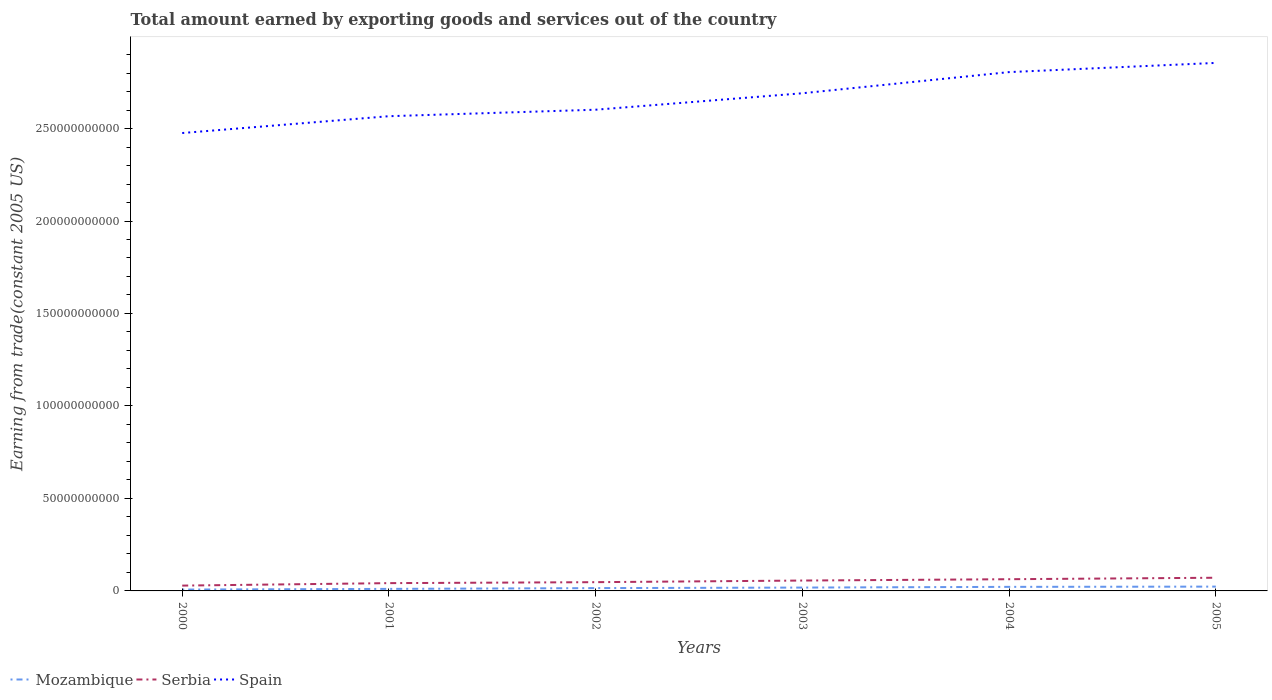How many different coloured lines are there?
Your answer should be very brief. 3. Does the line corresponding to Serbia intersect with the line corresponding to Spain?
Offer a terse response. No. Is the number of lines equal to the number of legend labels?
Provide a short and direct response. Yes. Across all years, what is the maximum total amount earned by exporting goods and services in Spain?
Offer a very short reply. 2.48e+11. In which year was the total amount earned by exporting goods and services in Mozambique maximum?
Your answer should be very brief. 2000. What is the total total amount earned by exporting goods and services in Spain in the graph?
Provide a succinct answer. -2.15e+1. What is the difference between the highest and the second highest total amount earned by exporting goods and services in Mozambique?
Offer a terse response. 1.60e+09. Is the total amount earned by exporting goods and services in Serbia strictly greater than the total amount earned by exporting goods and services in Spain over the years?
Provide a short and direct response. Yes. Does the graph contain any zero values?
Your answer should be compact. No. Does the graph contain grids?
Your answer should be compact. No. Where does the legend appear in the graph?
Your answer should be compact. Bottom left. How many legend labels are there?
Provide a short and direct response. 3. What is the title of the graph?
Offer a terse response. Total amount earned by exporting goods and services out of the country. Does "Dominica" appear as one of the legend labels in the graph?
Ensure brevity in your answer.  No. What is the label or title of the Y-axis?
Offer a very short reply. Earning from trade(constant 2005 US). What is the Earning from trade(constant 2005 US) in Mozambique in 2000?
Your answer should be compact. 7.31e+08. What is the Earning from trade(constant 2005 US) in Serbia in 2000?
Offer a very short reply. 2.88e+09. What is the Earning from trade(constant 2005 US) of Spain in 2000?
Provide a succinct answer. 2.48e+11. What is the Earning from trade(constant 2005 US) in Mozambique in 2001?
Make the answer very short. 1.10e+09. What is the Earning from trade(constant 2005 US) in Serbia in 2001?
Keep it short and to the point. 4.21e+09. What is the Earning from trade(constant 2005 US) in Spain in 2001?
Ensure brevity in your answer.  2.57e+11. What is the Earning from trade(constant 2005 US) of Mozambique in 2002?
Offer a terse response. 1.52e+09. What is the Earning from trade(constant 2005 US) in Serbia in 2002?
Your answer should be compact. 4.73e+09. What is the Earning from trade(constant 2005 US) of Spain in 2002?
Give a very brief answer. 2.60e+11. What is the Earning from trade(constant 2005 US) of Mozambique in 2003?
Offer a terse response. 1.81e+09. What is the Earning from trade(constant 2005 US) in Serbia in 2003?
Keep it short and to the point. 5.61e+09. What is the Earning from trade(constant 2005 US) of Spain in 2003?
Your answer should be very brief. 2.69e+11. What is the Earning from trade(constant 2005 US) of Mozambique in 2004?
Offer a terse response. 2.19e+09. What is the Earning from trade(constant 2005 US) of Serbia in 2004?
Your response must be concise. 6.33e+09. What is the Earning from trade(constant 2005 US) of Spain in 2004?
Provide a short and direct response. 2.81e+11. What is the Earning from trade(constant 2005 US) in Mozambique in 2005?
Keep it short and to the point. 2.33e+09. What is the Earning from trade(constant 2005 US) in Serbia in 2005?
Make the answer very short. 7.13e+09. What is the Earning from trade(constant 2005 US) of Spain in 2005?
Keep it short and to the point. 2.85e+11. Across all years, what is the maximum Earning from trade(constant 2005 US) of Mozambique?
Give a very brief answer. 2.33e+09. Across all years, what is the maximum Earning from trade(constant 2005 US) of Serbia?
Ensure brevity in your answer.  7.13e+09. Across all years, what is the maximum Earning from trade(constant 2005 US) of Spain?
Provide a short and direct response. 2.85e+11. Across all years, what is the minimum Earning from trade(constant 2005 US) of Mozambique?
Provide a short and direct response. 7.31e+08. Across all years, what is the minimum Earning from trade(constant 2005 US) of Serbia?
Ensure brevity in your answer.  2.88e+09. Across all years, what is the minimum Earning from trade(constant 2005 US) of Spain?
Ensure brevity in your answer.  2.48e+11. What is the total Earning from trade(constant 2005 US) of Mozambique in the graph?
Give a very brief answer. 9.69e+09. What is the total Earning from trade(constant 2005 US) of Serbia in the graph?
Provide a succinct answer. 3.09e+1. What is the total Earning from trade(constant 2005 US) of Spain in the graph?
Your answer should be compact. 1.60e+12. What is the difference between the Earning from trade(constant 2005 US) of Mozambique in 2000 and that in 2001?
Provide a succinct answer. -3.69e+08. What is the difference between the Earning from trade(constant 2005 US) of Serbia in 2000 and that in 2001?
Your answer should be very brief. -1.33e+09. What is the difference between the Earning from trade(constant 2005 US) of Spain in 2000 and that in 2001?
Your answer should be very brief. -9.10e+09. What is the difference between the Earning from trade(constant 2005 US) in Mozambique in 2000 and that in 2002?
Provide a short and direct response. -7.90e+08. What is the difference between the Earning from trade(constant 2005 US) of Serbia in 2000 and that in 2002?
Keep it short and to the point. -1.86e+09. What is the difference between the Earning from trade(constant 2005 US) in Spain in 2000 and that in 2002?
Offer a terse response. -1.26e+1. What is the difference between the Earning from trade(constant 2005 US) in Mozambique in 2000 and that in 2003?
Make the answer very short. -1.08e+09. What is the difference between the Earning from trade(constant 2005 US) in Serbia in 2000 and that in 2003?
Give a very brief answer. -2.73e+09. What is the difference between the Earning from trade(constant 2005 US) in Spain in 2000 and that in 2003?
Provide a short and direct response. -2.15e+1. What is the difference between the Earning from trade(constant 2005 US) of Mozambique in 2000 and that in 2004?
Give a very brief answer. -1.46e+09. What is the difference between the Earning from trade(constant 2005 US) of Serbia in 2000 and that in 2004?
Make the answer very short. -3.46e+09. What is the difference between the Earning from trade(constant 2005 US) of Spain in 2000 and that in 2004?
Ensure brevity in your answer.  -3.29e+1. What is the difference between the Earning from trade(constant 2005 US) of Mozambique in 2000 and that in 2005?
Offer a terse response. -1.60e+09. What is the difference between the Earning from trade(constant 2005 US) in Serbia in 2000 and that in 2005?
Your answer should be very brief. -4.25e+09. What is the difference between the Earning from trade(constant 2005 US) of Spain in 2000 and that in 2005?
Your response must be concise. -3.79e+1. What is the difference between the Earning from trade(constant 2005 US) of Mozambique in 2001 and that in 2002?
Keep it short and to the point. -4.21e+08. What is the difference between the Earning from trade(constant 2005 US) of Serbia in 2001 and that in 2002?
Ensure brevity in your answer.  -5.24e+08. What is the difference between the Earning from trade(constant 2005 US) in Spain in 2001 and that in 2002?
Provide a short and direct response. -3.51e+09. What is the difference between the Earning from trade(constant 2005 US) in Mozambique in 2001 and that in 2003?
Offer a very short reply. -7.10e+08. What is the difference between the Earning from trade(constant 2005 US) in Serbia in 2001 and that in 2003?
Give a very brief answer. -1.40e+09. What is the difference between the Earning from trade(constant 2005 US) of Spain in 2001 and that in 2003?
Provide a short and direct response. -1.24e+1. What is the difference between the Earning from trade(constant 2005 US) in Mozambique in 2001 and that in 2004?
Make the answer very short. -1.09e+09. What is the difference between the Earning from trade(constant 2005 US) in Serbia in 2001 and that in 2004?
Provide a short and direct response. -2.12e+09. What is the difference between the Earning from trade(constant 2005 US) of Spain in 2001 and that in 2004?
Give a very brief answer. -2.38e+1. What is the difference between the Earning from trade(constant 2005 US) in Mozambique in 2001 and that in 2005?
Your answer should be compact. -1.23e+09. What is the difference between the Earning from trade(constant 2005 US) of Serbia in 2001 and that in 2005?
Provide a short and direct response. -2.92e+09. What is the difference between the Earning from trade(constant 2005 US) in Spain in 2001 and that in 2005?
Make the answer very short. -2.88e+1. What is the difference between the Earning from trade(constant 2005 US) in Mozambique in 2002 and that in 2003?
Your answer should be very brief. -2.88e+08. What is the difference between the Earning from trade(constant 2005 US) in Serbia in 2002 and that in 2003?
Your answer should be very brief. -8.75e+08. What is the difference between the Earning from trade(constant 2005 US) of Spain in 2002 and that in 2003?
Give a very brief answer. -8.90e+09. What is the difference between the Earning from trade(constant 2005 US) in Mozambique in 2002 and that in 2004?
Provide a succinct answer. -6.73e+08. What is the difference between the Earning from trade(constant 2005 US) of Serbia in 2002 and that in 2004?
Ensure brevity in your answer.  -1.60e+09. What is the difference between the Earning from trade(constant 2005 US) in Spain in 2002 and that in 2004?
Ensure brevity in your answer.  -2.03e+1. What is the difference between the Earning from trade(constant 2005 US) of Mozambique in 2002 and that in 2005?
Offer a very short reply. -8.11e+08. What is the difference between the Earning from trade(constant 2005 US) in Serbia in 2002 and that in 2005?
Ensure brevity in your answer.  -2.39e+09. What is the difference between the Earning from trade(constant 2005 US) of Spain in 2002 and that in 2005?
Keep it short and to the point. -2.53e+1. What is the difference between the Earning from trade(constant 2005 US) of Mozambique in 2003 and that in 2004?
Offer a very short reply. -3.85e+08. What is the difference between the Earning from trade(constant 2005 US) of Serbia in 2003 and that in 2004?
Your answer should be compact. -7.25e+08. What is the difference between the Earning from trade(constant 2005 US) in Spain in 2003 and that in 2004?
Offer a terse response. -1.14e+1. What is the difference between the Earning from trade(constant 2005 US) of Mozambique in 2003 and that in 2005?
Ensure brevity in your answer.  -5.22e+08. What is the difference between the Earning from trade(constant 2005 US) of Serbia in 2003 and that in 2005?
Your response must be concise. -1.52e+09. What is the difference between the Earning from trade(constant 2005 US) in Spain in 2003 and that in 2005?
Keep it short and to the point. -1.64e+1. What is the difference between the Earning from trade(constant 2005 US) of Mozambique in 2004 and that in 2005?
Your answer should be compact. -1.38e+08. What is the difference between the Earning from trade(constant 2005 US) in Serbia in 2004 and that in 2005?
Your answer should be compact. -7.92e+08. What is the difference between the Earning from trade(constant 2005 US) in Spain in 2004 and that in 2005?
Your answer should be very brief. -4.97e+09. What is the difference between the Earning from trade(constant 2005 US) in Mozambique in 2000 and the Earning from trade(constant 2005 US) in Serbia in 2001?
Ensure brevity in your answer.  -3.48e+09. What is the difference between the Earning from trade(constant 2005 US) of Mozambique in 2000 and the Earning from trade(constant 2005 US) of Spain in 2001?
Provide a short and direct response. -2.56e+11. What is the difference between the Earning from trade(constant 2005 US) of Serbia in 2000 and the Earning from trade(constant 2005 US) of Spain in 2001?
Provide a succinct answer. -2.54e+11. What is the difference between the Earning from trade(constant 2005 US) of Mozambique in 2000 and the Earning from trade(constant 2005 US) of Serbia in 2002?
Ensure brevity in your answer.  -4.00e+09. What is the difference between the Earning from trade(constant 2005 US) of Mozambique in 2000 and the Earning from trade(constant 2005 US) of Spain in 2002?
Provide a short and direct response. -2.59e+11. What is the difference between the Earning from trade(constant 2005 US) of Serbia in 2000 and the Earning from trade(constant 2005 US) of Spain in 2002?
Ensure brevity in your answer.  -2.57e+11. What is the difference between the Earning from trade(constant 2005 US) in Mozambique in 2000 and the Earning from trade(constant 2005 US) in Serbia in 2003?
Provide a short and direct response. -4.88e+09. What is the difference between the Earning from trade(constant 2005 US) of Mozambique in 2000 and the Earning from trade(constant 2005 US) of Spain in 2003?
Make the answer very short. -2.68e+11. What is the difference between the Earning from trade(constant 2005 US) of Serbia in 2000 and the Earning from trade(constant 2005 US) of Spain in 2003?
Keep it short and to the point. -2.66e+11. What is the difference between the Earning from trade(constant 2005 US) in Mozambique in 2000 and the Earning from trade(constant 2005 US) in Serbia in 2004?
Your answer should be compact. -5.60e+09. What is the difference between the Earning from trade(constant 2005 US) of Mozambique in 2000 and the Earning from trade(constant 2005 US) of Spain in 2004?
Ensure brevity in your answer.  -2.80e+11. What is the difference between the Earning from trade(constant 2005 US) in Serbia in 2000 and the Earning from trade(constant 2005 US) in Spain in 2004?
Keep it short and to the point. -2.78e+11. What is the difference between the Earning from trade(constant 2005 US) of Mozambique in 2000 and the Earning from trade(constant 2005 US) of Serbia in 2005?
Make the answer very short. -6.39e+09. What is the difference between the Earning from trade(constant 2005 US) of Mozambique in 2000 and the Earning from trade(constant 2005 US) of Spain in 2005?
Offer a very short reply. -2.85e+11. What is the difference between the Earning from trade(constant 2005 US) in Serbia in 2000 and the Earning from trade(constant 2005 US) in Spain in 2005?
Give a very brief answer. -2.83e+11. What is the difference between the Earning from trade(constant 2005 US) of Mozambique in 2001 and the Earning from trade(constant 2005 US) of Serbia in 2002?
Your answer should be very brief. -3.63e+09. What is the difference between the Earning from trade(constant 2005 US) in Mozambique in 2001 and the Earning from trade(constant 2005 US) in Spain in 2002?
Ensure brevity in your answer.  -2.59e+11. What is the difference between the Earning from trade(constant 2005 US) of Serbia in 2001 and the Earning from trade(constant 2005 US) of Spain in 2002?
Make the answer very short. -2.56e+11. What is the difference between the Earning from trade(constant 2005 US) of Mozambique in 2001 and the Earning from trade(constant 2005 US) of Serbia in 2003?
Give a very brief answer. -4.51e+09. What is the difference between the Earning from trade(constant 2005 US) of Mozambique in 2001 and the Earning from trade(constant 2005 US) of Spain in 2003?
Offer a very short reply. -2.68e+11. What is the difference between the Earning from trade(constant 2005 US) of Serbia in 2001 and the Earning from trade(constant 2005 US) of Spain in 2003?
Offer a very short reply. -2.65e+11. What is the difference between the Earning from trade(constant 2005 US) in Mozambique in 2001 and the Earning from trade(constant 2005 US) in Serbia in 2004?
Offer a very short reply. -5.23e+09. What is the difference between the Earning from trade(constant 2005 US) of Mozambique in 2001 and the Earning from trade(constant 2005 US) of Spain in 2004?
Make the answer very short. -2.79e+11. What is the difference between the Earning from trade(constant 2005 US) in Serbia in 2001 and the Earning from trade(constant 2005 US) in Spain in 2004?
Keep it short and to the point. -2.76e+11. What is the difference between the Earning from trade(constant 2005 US) of Mozambique in 2001 and the Earning from trade(constant 2005 US) of Serbia in 2005?
Provide a succinct answer. -6.03e+09. What is the difference between the Earning from trade(constant 2005 US) in Mozambique in 2001 and the Earning from trade(constant 2005 US) in Spain in 2005?
Your response must be concise. -2.84e+11. What is the difference between the Earning from trade(constant 2005 US) of Serbia in 2001 and the Earning from trade(constant 2005 US) of Spain in 2005?
Offer a terse response. -2.81e+11. What is the difference between the Earning from trade(constant 2005 US) in Mozambique in 2002 and the Earning from trade(constant 2005 US) in Serbia in 2003?
Provide a short and direct response. -4.09e+09. What is the difference between the Earning from trade(constant 2005 US) of Mozambique in 2002 and the Earning from trade(constant 2005 US) of Spain in 2003?
Offer a very short reply. -2.68e+11. What is the difference between the Earning from trade(constant 2005 US) in Serbia in 2002 and the Earning from trade(constant 2005 US) in Spain in 2003?
Your answer should be compact. -2.64e+11. What is the difference between the Earning from trade(constant 2005 US) in Mozambique in 2002 and the Earning from trade(constant 2005 US) in Serbia in 2004?
Provide a short and direct response. -4.81e+09. What is the difference between the Earning from trade(constant 2005 US) of Mozambique in 2002 and the Earning from trade(constant 2005 US) of Spain in 2004?
Ensure brevity in your answer.  -2.79e+11. What is the difference between the Earning from trade(constant 2005 US) of Serbia in 2002 and the Earning from trade(constant 2005 US) of Spain in 2004?
Make the answer very short. -2.76e+11. What is the difference between the Earning from trade(constant 2005 US) in Mozambique in 2002 and the Earning from trade(constant 2005 US) in Serbia in 2005?
Ensure brevity in your answer.  -5.60e+09. What is the difference between the Earning from trade(constant 2005 US) of Mozambique in 2002 and the Earning from trade(constant 2005 US) of Spain in 2005?
Your answer should be compact. -2.84e+11. What is the difference between the Earning from trade(constant 2005 US) in Serbia in 2002 and the Earning from trade(constant 2005 US) in Spain in 2005?
Give a very brief answer. -2.81e+11. What is the difference between the Earning from trade(constant 2005 US) in Mozambique in 2003 and the Earning from trade(constant 2005 US) in Serbia in 2004?
Give a very brief answer. -4.52e+09. What is the difference between the Earning from trade(constant 2005 US) in Mozambique in 2003 and the Earning from trade(constant 2005 US) in Spain in 2004?
Ensure brevity in your answer.  -2.79e+11. What is the difference between the Earning from trade(constant 2005 US) in Serbia in 2003 and the Earning from trade(constant 2005 US) in Spain in 2004?
Offer a terse response. -2.75e+11. What is the difference between the Earning from trade(constant 2005 US) of Mozambique in 2003 and the Earning from trade(constant 2005 US) of Serbia in 2005?
Make the answer very short. -5.32e+09. What is the difference between the Earning from trade(constant 2005 US) of Mozambique in 2003 and the Earning from trade(constant 2005 US) of Spain in 2005?
Make the answer very short. -2.84e+11. What is the difference between the Earning from trade(constant 2005 US) of Serbia in 2003 and the Earning from trade(constant 2005 US) of Spain in 2005?
Your answer should be compact. -2.80e+11. What is the difference between the Earning from trade(constant 2005 US) in Mozambique in 2004 and the Earning from trade(constant 2005 US) in Serbia in 2005?
Your answer should be very brief. -4.93e+09. What is the difference between the Earning from trade(constant 2005 US) in Mozambique in 2004 and the Earning from trade(constant 2005 US) in Spain in 2005?
Keep it short and to the point. -2.83e+11. What is the difference between the Earning from trade(constant 2005 US) in Serbia in 2004 and the Earning from trade(constant 2005 US) in Spain in 2005?
Your response must be concise. -2.79e+11. What is the average Earning from trade(constant 2005 US) in Mozambique per year?
Your answer should be compact. 1.61e+09. What is the average Earning from trade(constant 2005 US) in Serbia per year?
Your answer should be compact. 5.15e+09. What is the average Earning from trade(constant 2005 US) of Spain per year?
Your answer should be very brief. 2.67e+11. In the year 2000, what is the difference between the Earning from trade(constant 2005 US) in Mozambique and Earning from trade(constant 2005 US) in Serbia?
Offer a very short reply. -2.14e+09. In the year 2000, what is the difference between the Earning from trade(constant 2005 US) in Mozambique and Earning from trade(constant 2005 US) in Spain?
Ensure brevity in your answer.  -2.47e+11. In the year 2000, what is the difference between the Earning from trade(constant 2005 US) of Serbia and Earning from trade(constant 2005 US) of Spain?
Your answer should be very brief. -2.45e+11. In the year 2001, what is the difference between the Earning from trade(constant 2005 US) of Mozambique and Earning from trade(constant 2005 US) of Serbia?
Your answer should be compact. -3.11e+09. In the year 2001, what is the difference between the Earning from trade(constant 2005 US) in Mozambique and Earning from trade(constant 2005 US) in Spain?
Offer a very short reply. -2.56e+11. In the year 2001, what is the difference between the Earning from trade(constant 2005 US) in Serbia and Earning from trade(constant 2005 US) in Spain?
Provide a short and direct response. -2.52e+11. In the year 2002, what is the difference between the Earning from trade(constant 2005 US) of Mozambique and Earning from trade(constant 2005 US) of Serbia?
Your response must be concise. -3.21e+09. In the year 2002, what is the difference between the Earning from trade(constant 2005 US) of Mozambique and Earning from trade(constant 2005 US) of Spain?
Ensure brevity in your answer.  -2.59e+11. In the year 2002, what is the difference between the Earning from trade(constant 2005 US) in Serbia and Earning from trade(constant 2005 US) in Spain?
Make the answer very short. -2.55e+11. In the year 2003, what is the difference between the Earning from trade(constant 2005 US) of Mozambique and Earning from trade(constant 2005 US) of Serbia?
Offer a terse response. -3.80e+09. In the year 2003, what is the difference between the Earning from trade(constant 2005 US) in Mozambique and Earning from trade(constant 2005 US) in Spain?
Offer a terse response. -2.67e+11. In the year 2003, what is the difference between the Earning from trade(constant 2005 US) in Serbia and Earning from trade(constant 2005 US) in Spain?
Give a very brief answer. -2.63e+11. In the year 2004, what is the difference between the Earning from trade(constant 2005 US) in Mozambique and Earning from trade(constant 2005 US) in Serbia?
Provide a succinct answer. -4.14e+09. In the year 2004, what is the difference between the Earning from trade(constant 2005 US) of Mozambique and Earning from trade(constant 2005 US) of Spain?
Provide a succinct answer. -2.78e+11. In the year 2004, what is the difference between the Earning from trade(constant 2005 US) of Serbia and Earning from trade(constant 2005 US) of Spain?
Your response must be concise. -2.74e+11. In the year 2005, what is the difference between the Earning from trade(constant 2005 US) of Mozambique and Earning from trade(constant 2005 US) of Serbia?
Give a very brief answer. -4.79e+09. In the year 2005, what is the difference between the Earning from trade(constant 2005 US) in Mozambique and Earning from trade(constant 2005 US) in Spain?
Keep it short and to the point. -2.83e+11. In the year 2005, what is the difference between the Earning from trade(constant 2005 US) in Serbia and Earning from trade(constant 2005 US) in Spain?
Your response must be concise. -2.78e+11. What is the ratio of the Earning from trade(constant 2005 US) in Mozambique in 2000 to that in 2001?
Give a very brief answer. 0.66. What is the ratio of the Earning from trade(constant 2005 US) in Serbia in 2000 to that in 2001?
Ensure brevity in your answer.  0.68. What is the ratio of the Earning from trade(constant 2005 US) in Spain in 2000 to that in 2001?
Offer a very short reply. 0.96. What is the ratio of the Earning from trade(constant 2005 US) of Mozambique in 2000 to that in 2002?
Your answer should be very brief. 0.48. What is the ratio of the Earning from trade(constant 2005 US) of Serbia in 2000 to that in 2002?
Give a very brief answer. 0.61. What is the ratio of the Earning from trade(constant 2005 US) of Spain in 2000 to that in 2002?
Ensure brevity in your answer.  0.95. What is the ratio of the Earning from trade(constant 2005 US) in Mozambique in 2000 to that in 2003?
Your answer should be very brief. 0.4. What is the ratio of the Earning from trade(constant 2005 US) in Serbia in 2000 to that in 2003?
Keep it short and to the point. 0.51. What is the ratio of the Earning from trade(constant 2005 US) of Spain in 2000 to that in 2003?
Your answer should be very brief. 0.92. What is the ratio of the Earning from trade(constant 2005 US) in Mozambique in 2000 to that in 2004?
Your answer should be very brief. 0.33. What is the ratio of the Earning from trade(constant 2005 US) in Serbia in 2000 to that in 2004?
Your response must be concise. 0.45. What is the ratio of the Earning from trade(constant 2005 US) of Spain in 2000 to that in 2004?
Keep it short and to the point. 0.88. What is the ratio of the Earning from trade(constant 2005 US) in Mozambique in 2000 to that in 2005?
Offer a terse response. 0.31. What is the ratio of the Earning from trade(constant 2005 US) of Serbia in 2000 to that in 2005?
Provide a short and direct response. 0.4. What is the ratio of the Earning from trade(constant 2005 US) in Spain in 2000 to that in 2005?
Your response must be concise. 0.87. What is the ratio of the Earning from trade(constant 2005 US) in Mozambique in 2001 to that in 2002?
Provide a short and direct response. 0.72. What is the ratio of the Earning from trade(constant 2005 US) in Serbia in 2001 to that in 2002?
Your answer should be compact. 0.89. What is the ratio of the Earning from trade(constant 2005 US) in Spain in 2001 to that in 2002?
Provide a succinct answer. 0.99. What is the ratio of the Earning from trade(constant 2005 US) of Mozambique in 2001 to that in 2003?
Your answer should be very brief. 0.61. What is the ratio of the Earning from trade(constant 2005 US) in Serbia in 2001 to that in 2003?
Provide a succinct answer. 0.75. What is the ratio of the Earning from trade(constant 2005 US) in Spain in 2001 to that in 2003?
Ensure brevity in your answer.  0.95. What is the ratio of the Earning from trade(constant 2005 US) of Mozambique in 2001 to that in 2004?
Offer a terse response. 0.5. What is the ratio of the Earning from trade(constant 2005 US) in Serbia in 2001 to that in 2004?
Your answer should be very brief. 0.66. What is the ratio of the Earning from trade(constant 2005 US) of Spain in 2001 to that in 2004?
Keep it short and to the point. 0.92. What is the ratio of the Earning from trade(constant 2005 US) in Mozambique in 2001 to that in 2005?
Your response must be concise. 0.47. What is the ratio of the Earning from trade(constant 2005 US) of Serbia in 2001 to that in 2005?
Your answer should be compact. 0.59. What is the ratio of the Earning from trade(constant 2005 US) of Spain in 2001 to that in 2005?
Your response must be concise. 0.9. What is the ratio of the Earning from trade(constant 2005 US) of Mozambique in 2002 to that in 2003?
Offer a terse response. 0.84. What is the ratio of the Earning from trade(constant 2005 US) of Serbia in 2002 to that in 2003?
Give a very brief answer. 0.84. What is the ratio of the Earning from trade(constant 2005 US) of Spain in 2002 to that in 2003?
Provide a succinct answer. 0.97. What is the ratio of the Earning from trade(constant 2005 US) in Mozambique in 2002 to that in 2004?
Provide a short and direct response. 0.69. What is the ratio of the Earning from trade(constant 2005 US) of Serbia in 2002 to that in 2004?
Give a very brief answer. 0.75. What is the ratio of the Earning from trade(constant 2005 US) in Spain in 2002 to that in 2004?
Your answer should be very brief. 0.93. What is the ratio of the Earning from trade(constant 2005 US) of Mozambique in 2002 to that in 2005?
Offer a terse response. 0.65. What is the ratio of the Earning from trade(constant 2005 US) in Serbia in 2002 to that in 2005?
Your response must be concise. 0.66. What is the ratio of the Earning from trade(constant 2005 US) in Spain in 2002 to that in 2005?
Your response must be concise. 0.91. What is the ratio of the Earning from trade(constant 2005 US) of Mozambique in 2003 to that in 2004?
Give a very brief answer. 0.82. What is the ratio of the Earning from trade(constant 2005 US) in Serbia in 2003 to that in 2004?
Give a very brief answer. 0.89. What is the ratio of the Earning from trade(constant 2005 US) of Spain in 2003 to that in 2004?
Ensure brevity in your answer.  0.96. What is the ratio of the Earning from trade(constant 2005 US) of Mozambique in 2003 to that in 2005?
Keep it short and to the point. 0.78. What is the ratio of the Earning from trade(constant 2005 US) of Serbia in 2003 to that in 2005?
Provide a short and direct response. 0.79. What is the ratio of the Earning from trade(constant 2005 US) in Spain in 2003 to that in 2005?
Make the answer very short. 0.94. What is the ratio of the Earning from trade(constant 2005 US) in Mozambique in 2004 to that in 2005?
Offer a terse response. 0.94. What is the ratio of the Earning from trade(constant 2005 US) in Spain in 2004 to that in 2005?
Offer a very short reply. 0.98. What is the difference between the highest and the second highest Earning from trade(constant 2005 US) of Mozambique?
Provide a succinct answer. 1.38e+08. What is the difference between the highest and the second highest Earning from trade(constant 2005 US) of Serbia?
Offer a very short reply. 7.92e+08. What is the difference between the highest and the second highest Earning from trade(constant 2005 US) in Spain?
Keep it short and to the point. 4.97e+09. What is the difference between the highest and the lowest Earning from trade(constant 2005 US) in Mozambique?
Offer a terse response. 1.60e+09. What is the difference between the highest and the lowest Earning from trade(constant 2005 US) of Serbia?
Provide a short and direct response. 4.25e+09. What is the difference between the highest and the lowest Earning from trade(constant 2005 US) in Spain?
Give a very brief answer. 3.79e+1. 